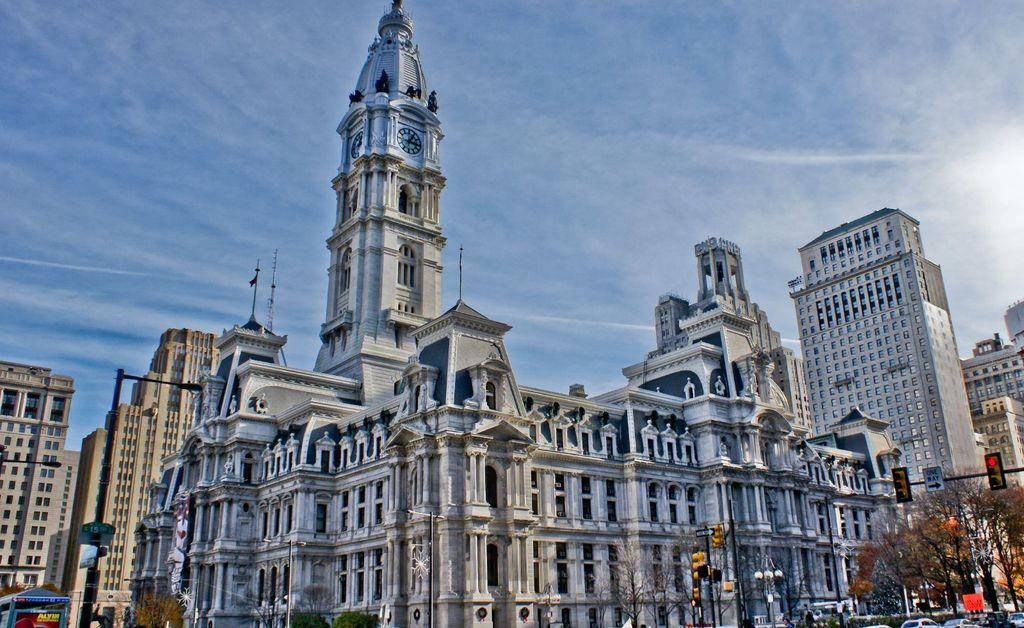What type of structures can be seen in the image? There are buildings in the image. What type of natural elements are present in the image? There are trees in the image. What type of man-made objects are visible in the image? There are vehicles in the image. How many goldfish are swimming in the water in the image? There are no goldfish present in the image. What type of fruit can be seen hanging from the trees in the image? There is no fruit hanging from the trees in the image. 